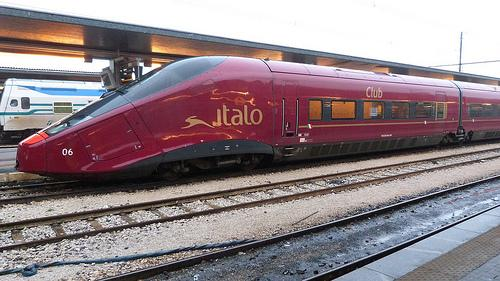Elaborate on the overall setting depicted in the image. The image showcases a train station with two bullet trains, sets of railroad tracks, an empty platform, and various lighting arrangements. Give a concise description of the trains and their surroundings. Two trains, one maroon and another white and aqua, are on tracks at a station with ceiling lights, an empty platform, and a blue and white camper nearby. Mention the main colors and features of the trains in the image. A sleek maroon train has a red nose and gold windows, while a white and aqua train features a blue and white camper. In simple terms, describe the key elements of the photo. There are two trains, some tracks, a platform, and lights in the picture. Provide a brief overview of the image scene. A sleek maroon train and a white and aqua train are stationed at a platform with a bright white sky overhead and multiple railroad tracks underneath. Write a brief summary of what's happening in the image. Two distinct bullet trains are parked at a train station with multiple tracks, lights, and a seemingly empty platform. List some key objects observed in the picture. Maroon train, white and aqua train, railroad tracks, empty platform, ceiling lights, gold windows, train labels, and a blue and white camper. Provide a general description of the image's content. The image features two bullet trains of different colors at a well-lit train station with an empty platform and multiple railroad tracks. Express the scene using five descriptive words. Maroon, aqua, trains, railroad tracks, platform. Describe any unique features of the trains in the image. The maroon train has a red nose, gold windows, and train label written in gold while the white and aqua train features a blue and white camper. 